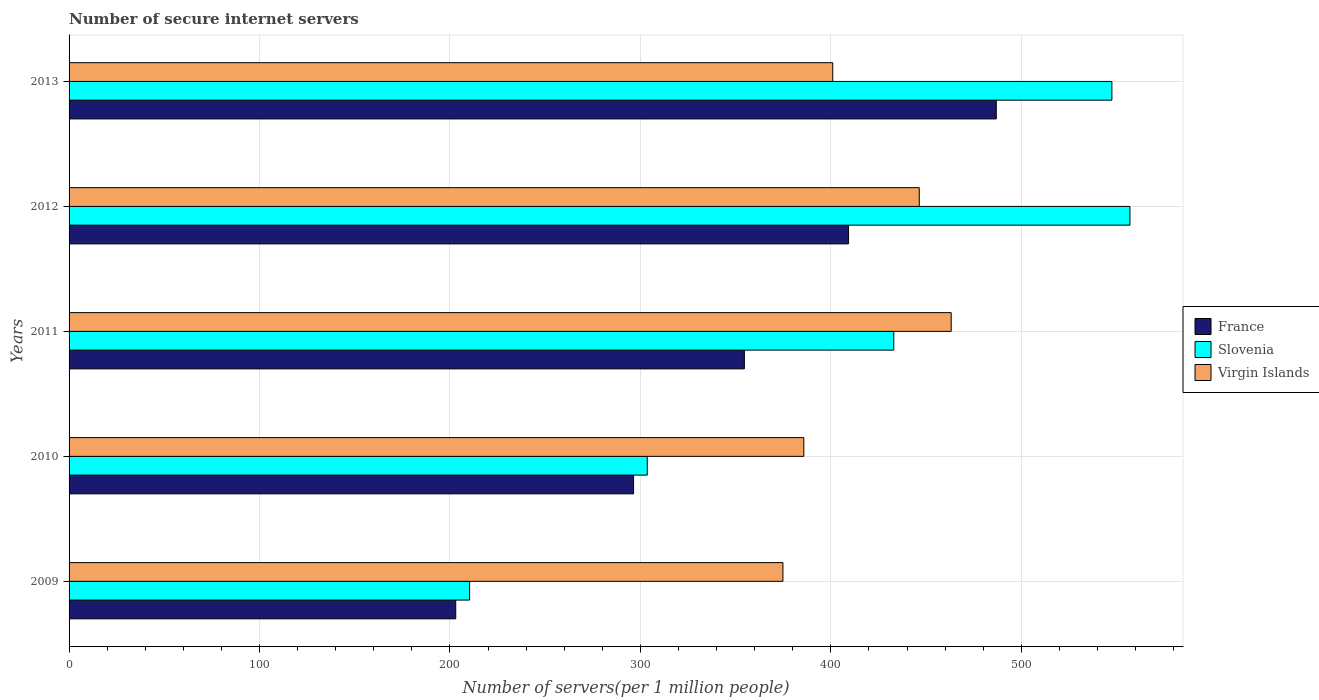How many groups of bars are there?
Keep it short and to the point. 5. Are the number of bars per tick equal to the number of legend labels?
Make the answer very short. Yes. How many bars are there on the 3rd tick from the top?
Your response must be concise. 3. How many bars are there on the 3rd tick from the bottom?
Provide a short and direct response. 3. What is the label of the 1st group of bars from the top?
Give a very brief answer. 2013. In how many cases, is the number of bars for a given year not equal to the number of legend labels?
Offer a terse response. 0. What is the number of secure internet servers in Virgin Islands in 2010?
Your answer should be very brief. 385.82. Across all years, what is the maximum number of secure internet servers in Virgin Islands?
Keep it short and to the point. 463.21. Across all years, what is the minimum number of secure internet servers in France?
Provide a succinct answer. 203.04. In which year was the number of secure internet servers in Slovenia maximum?
Your response must be concise. 2012. In which year was the number of secure internet servers in Slovenia minimum?
Give a very brief answer. 2009. What is the total number of secure internet servers in Slovenia in the graph?
Ensure brevity in your answer.  2051.67. What is the difference between the number of secure internet servers in France in 2011 and that in 2013?
Your answer should be very brief. -132.28. What is the difference between the number of secure internet servers in France in 2010 and the number of secure internet servers in Slovenia in 2011?
Provide a short and direct response. -136.64. What is the average number of secure internet servers in Virgin Islands per year?
Provide a short and direct response. 414.27. In the year 2013, what is the difference between the number of secure internet servers in Virgin Islands and number of secure internet servers in Slovenia?
Provide a succinct answer. -146.58. In how many years, is the number of secure internet servers in France greater than 160 ?
Offer a terse response. 5. What is the ratio of the number of secure internet servers in Slovenia in 2011 to that in 2012?
Your answer should be compact. 0.78. Is the number of secure internet servers in France in 2009 less than that in 2013?
Offer a terse response. Yes. Is the difference between the number of secure internet servers in Virgin Islands in 2010 and 2011 greater than the difference between the number of secure internet servers in Slovenia in 2010 and 2011?
Offer a very short reply. Yes. What is the difference between the highest and the second highest number of secure internet servers in France?
Offer a very short reply. 77.57. What is the difference between the highest and the lowest number of secure internet servers in France?
Your answer should be very brief. 283.84. What does the 2nd bar from the top in 2011 represents?
Keep it short and to the point. Slovenia. What does the 3rd bar from the bottom in 2012 represents?
Offer a very short reply. Virgin Islands. How many bars are there?
Your answer should be compact. 15. What is the difference between two consecutive major ticks on the X-axis?
Your answer should be very brief. 100. How many legend labels are there?
Your answer should be very brief. 3. What is the title of the graph?
Make the answer very short. Number of secure internet servers. Does "Panama" appear as one of the legend labels in the graph?
Provide a short and direct response. No. What is the label or title of the X-axis?
Ensure brevity in your answer.  Number of servers(per 1 million people). What is the Number of servers(per 1 million people) of France in 2009?
Your answer should be very brief. 203.04. What is the Number of servers(per 1 million people) in Slovenia in 2009?
Offer a terse response. 210.33. What is the Number of servers(per 1 million people) in Virgin Islands in 2009?
Provide a succinct answer. 374.86. What is the Number of servers(per 1 million people) in France in 2010?
Provide a short and direct response. 296.41. What is the Number of servers(per 1 million people) of Slovenia in 2010?
Ensure brevity in your answer.  303.62. What is the Number of servers(per 1 million people) of Virgin Islands in 2010?
Provide a short and direct response. 385.82. What is the Number of servers(per 1 million people) of France in 2011?
Provide a succinct answer. 354.61. What is the Number of servers(per 1 million people) in Slovenia in 2011?
Your answer should be compact. 433.06. What is the Number of servers(per 1 million people) of Virgin Islands in 2011?
Ensure brevity in your answer.  463.21. What is the Number of servers(per 1 million people) of France in 2012?
Offer a terse response. 409.31. What is the Number of servers(per 1 million people) of Slovenia in 2012?
Your response must be concise. 557.08. What is the Number of servers(per 1 million people) in Virgin Islands in 2012?
Your answer should be compact. 446.45. What is the Number of servers(per 1 million people) of France in 2013?
Give a very brief answer. 486.88. What is the Number of servers(per 1 million people) in Slovenia in 2013?
Provide a succinct answer. 547.59. What is the Number of servers(per 1 million people) in Virgin Islands in 2013?
Ensure brevity in your answer.  401. Across all years, what is the maximum Number of servers(per 1 million people) in France?
Offer a very short reply. 486.88. Across all years, what is the maximum Number of servers(per 1 million people) of Slovenia?
Make the answer very short. 557.08. Across all years, what is the maximum Number of servers(per 1 million people) of Virgin Islands?
Your answer should be very brief. 463.21. Across all years, what is the minimum Number of servers(per 1 million people) in France?
Provide a succinct answer. 203.04. Across all years, what is the minimum Number of servers(per 1 million people) of Slovenia?
Keep it short and to the point. 210.33. Across all years, what is the minimum Number of servers(per 1 million people) of Virgin Islands?
Your response must be concise. 374.86. What is the total Number of servers(per 1 million people) of France in the graph?
Offer a terse response. 1750.25. What is the total Number of servers(per 1 million people) of Slovenia in the graph?
Make the answer very short. 2051.68. What is the total Number of servers(per 1 million people) in Virgin Islands in the graph?
Your answer should be compact. 2071.34. What is the difference between the Number of servers(per 1 million people) in France in 2009 and that in 2010?
Your answer should be compact. -93.37. What is the difference between the Number of servers(per 1 million people) of Slovenia in 2009 and that in 2010?
Give a very brief answer. -93.3. What is the difference between the Number of servers(per 1 million people) in Virgin Islands in 2009 and that in 2010?
Your answer should be very brief. -10.96. What is the difference between the Number of servers(per 1 million people) in France in 2009 and that in 2011?
Provide a short and direct response. -151.57. What is the difference between the Number of servers(per 1 million people) of Slovenia in 2009 and that in 2011?
Give a very brief answer. -222.73. What is the difference between the Number of servers(per 1 million people) of Virgin Islands in 2009 and that in 2011?
Keep it short and to the point. -88.35. What is the difference between the Number of servers(per 1 million people) of France in 2009 and that in 2012?
Your answer should be compact. -206.27. What is the difference between the Number of servers(per 1 million people) in Slovenia in 2009 and that in 2012?
Ensure brevity in your answer.  -346.75. What is the difference between the Number of servers(per 1 million people) of Virgin Islands in 2009 and that in 2012?
Give a very brief answer. -71.59. What is the difference between the Number of servers(per 1 million people) of France in 2009 and that in 2013?
Offer a very short reply. -283.84. What is the difference between the Number of servers(per 1 million people) in Slovenia in 2009 and that in 2013?
Offer a very short reply. -337.26. What is the difference between the Number of servers(per 1 million people) in Virgin Islands in 2009 and that in 2013?
Your response must be concise. -26.15. What is the difference between the Number of servers(per 1 million people) of France in 2010 and that in 2011?
Make the answer very short. -58.19. What is the difference between the Number of servers(per 1 million people) in Slovenia in 2010 and that in 2011?
Give a very brief answer. -129.43. What is the difference between the Number of servers(per 1 million people) in Virgin Islands in 2010 and that in 2011?
Provide a succinct answer. -77.39. What is the difference between the Number of servers(per 1 million people) of France in 2010 and that in 2012?
Your response must be concise. -112.9. What is the difference between the Number of servers(per 1 million people) in Slovenia in 2010 and that in 2012?
Offer a very short reply. -253.45. What is the difference between the Number of servers(per 1 million people) of Virgin Islands in 2010 and that in 2012?
Give a very brief answer. -60.63. What is the difference between the Number of servers(per 1 million people) of France in 2010 and that in 2013?
Your answer should be very brief. -190.47. What is the difference between the Number of servers(per 1 million people) of Slovenia in 2010 and that in 2013?
Your answer should be very brief. -243.96. What is the difference between the Number of servers(per 1 million people) in Virgin Islands in 2010 and that in 2013?
Provide a short and direct response. -15.18. What is the difference between the Number of servers(per 1 million people) of France in 2011 and that in 2012?
Ensure brevity in your answer.  -54.7. What is the difference between the Number of servers(per 1 million people) in Slovenia in 2011 and that in 2012?
Ensure brevity in your answer.  -124.02. What is the difference between the Number of servers(per 1 million people) of Virgin Islands in 2011 and that in 2012?
Your response must be concise. 16.76. What is the difference between the Number of servers(per 1 million people) in France in 2011 and that in 2013?
Your answer should be compact. -132.28. What is the difference between the Number of servers(per 1 million people) in Slovenia in 2011 and that in 2013?
Offer a terse response. -114.53. What is the difference between the Number of servers(per 1 million people) in Virgin Islands in 2011 and that in 2013?
Offer a very short reply. 62.2. What is the difference between the Number of servers(per 1 million people) in France in 2012 and that in 2013?
Give a very brief answer. -77.57. What is the difference between the Number of servers(per 1 million people) in Slovenia in 2012 and that in 2013?
Offer a terse response. 9.49. What is the difference between the Number of servers(per 1 million people) in Virgin Islands in 2012 and that in 2013?
Your answer should be very brief. 45.45. What is the difference between the Number of servers(per 1 million people) of France in 2009 and the Number of servers(per 1 million people) of Slovenia in 2010?
Your answer should be very brief. -100.59. What is the difference between the Number of servers(per 1 million people) of France in 2009 and the Number of servers(per 1 million people) of Virgin Islands in 2010?
Your answer should be very brief. -182.78. What is the difference between the Number of servers(per 1 million people) in Slovenia in 2009 and the Number of servers(per 1 million people) in Virgin Islands in 2010?
Offer a very short reply. -175.49. What is the difference between the Number of servers(per 1 million people) of France in 2009 and the Number of servers(per 1 million people) of Slovenia in 2011?
Offer a very short reply. -230.02. What is the difference between the Number of servers(per 1 million people) of France in 2009 and the Number of servers(per 1 million people) of Virgin Islands in 2011?
Your response must be concise. -260.17. What is the difference between the Number of servers(per 1 million people) of Slovenia in 2009 and the Number of servers(per 1 million people) of Virgin Islands in 2011?
Your answer should be very brief. -252.88. What is the difference between the Number of servers(per 1 million people) in France in 2009 and the Number of servers(per 1 million people) in Slovenia in 2012?
Your answer should be compact. -354.04. What is the difference between the Number of servers(per 1 million people) in France in 2009 and the Number of servers(per 1 million people) in Virgin Islands in 2012?
Offer a very short reply. -243.41. What is the difference between the Number of servers(per 1 million people) of Slovenia in 2009 and the Number of servers(per 1 million people) of Virgin Islands in 2012?
Your answer should be very brief. -236.12. What is the difference between the Number of servers(per 1 million people) of France in 2009 and the Number of servers(per 1 million people) of Slovenia in 2013?
Keep it short and to the point. -344.55. What is the difference between the Number of servers(per 1 million people) in France in 2009 and the Number of servers(per 1 million people) in Virgin Islands in 2013?
Your response must be concise. -197.97. What is the difference between the Number of servers(per 1 million people) of Slovenia in 2009 and the Number of servers(per 1 million people) of Virgin Islands in 2013?
Offer a very short reply. -190.68. What is the difference between the Number of servers(per 1 million people) of France in 2010 and the Number of servers(per 1 million people) of Slovenia in 2011?
Your answer should be very brief. -136.65. What is the difference between the Number of servers(per 1 million people) in France in 2010 and the Number of servers(per 1 million people) in Virgin Islands in 2011?
Give a very brief answer. -166.79. What is the difference between the Number of servers(per 1 million people) of Slovenia in 2010 and the Number of servers(per 1 million people) of Virgin Islands in 2011?
Your answer should be very brief. -159.58. What is the difference between the Number of servers(per 1 million people) in France in 2010 and the Number of servers(per 1 million people) in Slovenia in 2012?
Your answer should be very brief. -260.67. What is the difference between the Number of servers(per 1 million people) in France in 2010 and the Number of servers(per 1 million people) in Virgin Islands in 2012?
Offer a terse response. -150.04. What is the difference between the Number of servers(per 1 million people) in Slovenia in 2010 and the Number of servers(per 1 million people) in Virgin Islands in 2012?
Ensure brevity in your answer.  -142.83. What is the difference between the Number of servers(per 1 million people) in France in 2010 and the Number of servers(per 1 million people) in Slovenia in 2013?
Your response must be concise. -251.17. What is the difference between the Number of servers(per 1 million people) in France in 2010 and the Number of servers(per 1 million people) in Virgin Islands in 2013?
Give a very brief answer. -104.59. What is the difference between the Number of servers(per 1 million people) in Slovenia in 2010 and the Number of servers(per 1 million people) in Virgin Islands in 2013?
Your response must be concise. -97.38. What is the difference between the Number of servers(per 1 million people) of France in 2011 and the Number of servers(per 1 million people) of Slovenia in 2012?
Your answer should be compact. -202.47. What is the difference between the Number of servers(per 1 million people) of France in 2011 and the Number of servers(per 1 million people) of Virgin Islands in 2012?
Keep it short and to the point. -91.84. What is the difference between the Number of servers(per 1 million people) of Slovenia in 2011 and the Number of servers(per 1 million people) of Virgin Islands in 2012?
Offer a terse response. -13.39. What is the difference between the Number of servers(per 1 million people) of France in 2011 and the Number of servers(per 1 million people) of Slovenia in 2013?
Keep it short and to the point. -192.98. What is the difference between the Number of servers(per 1 million people) of France in 2011 and the Number of servers(per 1 million people) of Virgin Islands in 2013?
Provide a short and direct response. -46.4. What is the difference between the Number of servers(per 1 million people) of Slovenia in 2011 and the Number of servers(per 1 million people) of Virgin Islands in 2013?
Provide a succinct answer. 32.05. What is the difference between the Number of servers(per 1 million people) of France in 2012 and the Number of servers(per 1 million people) of Slovenia in 2013?
Your response must be concise. -138.28. What is the difference between the Number of servers(per 1 million people) in France in 2012 and the Number of servers(per 1 million people) in Virgin Islands in 2013?
Your response must be concise. 8.3. What is the difference between the Number of servers(per 1 million people) of Slovenia in 2012 and the Number of servers(per 1 million people) of Virgin Islands in 2013?
Keep it short and to the point. 156.07. What is the average Number of servers(per 1 million people) in France per year?
Provide a short and direct response. 350.05. What is the average Number of servers(per 1 million people) in Slovenia per year?
Offer a terse response. 410.33. What is the average Number of servers(per 1 million people) of Virgin Islands per year?
Your answer should be very brief. 414.27. In the year 2009, what is the difference between the Number of servers(per 1 million people) in France and Number of servers(per 1 million people) in Slovenia?
Offer a terse response. -7.29. In the year 2009, what is the difference between the Number of servers(per 1 million people) in France and Number of servers(per 1 million people) in Virgin Islands?
Give a very brief answer. -171.82. In the year 2009, what is the difference between the Number of servers(per 1 million people) of Slovenia and Number of servers(per 1 million people) of Virgin Islands?
Provide a succinct answer. -164.53. In the year 2010, what is the difference between the Number of servers(per 1 million people) of France and Number of servers(per 1 million people) of Slovenia?
Your response must be concise. -7.21. In the year 2010, what is the difference between the Number of servers(per 1 million people) of France and Number of servers(per 1 million people) of Virgin Islands?
Offer a terse response. -89.41. In the year 2010, what is the difference between the Number of servers(per 1 million people) of Slovenia and Number of servers(per 1 million people) of Virgin Islands?
Ensure brevity in your answer.  -82.2. In the year 2011, what is the difference between the Number of servers(per 1 million people) of France and Number of servers(per 1 million people) of Slovenia?
Your answer should be very brief. -78.45. In the year 2011, what is the difference between the Number of servers(per 1 million people) of France and Number of servers(per 1 million people) of Virgin Islands?
Offer a terse response. -108.6. In the year 2011, what is the difference between the Number of servers(per 1 million people) in Slovenia and Number of servers(per 1 million people) in Virgin Islands?
Keep it short and to the point. -30.15. In the year 2012, what is the difference between the Number of servers(per 1 million people) of France and Number of servers(per 1 million people) of Slovenia?
Give a very brief answer. -147.77. In the year 2012, what is the difference between the Number of servers(per 1 million people) in France and Number of servers(per 1 million people) in Virgin Islands?
Provide a short and direct response. -37.14. In the year 2012, what is the difference between the Number of servers(per 1 million people) in Slovenia and Number of servers(per 1 million people) in Virgin Islands?
Provide a short and direct response. 110.63. In the year 2013, what is the difference between the Number of servers(per 1 million people) in France and Number of servers(per 1 million people) in Slovenia?
Your answer should be very brief. -60.7. In the year 2013, what is the difference between the Number of servers(per 1 million people) in France and Number of servers(per 1 million people) in Virgin Islands?
Make the answer very short. 85.88. In the year 2013, what is the difference between the Number of servers(per 1 million people) in Slovenia and Number of servers(per 1 million people) in Virgin Islands?
Make the answer very short. 146.58. What is the ratio of the Number of servers(per 1 million people) of France in 2009 to that in 2010?
Offer a very short reply. 0.69. What is the ratio of the Number of servers(per 1 million people) in Slovenia in 2009 to that in 2010?
Make the answer very short. 0.69. What is the ratio of the Number of servers(per 1 million people) in Virgin Islands in 2009 to that in 2010?
Provide a short and direct response. 0.97. What is the ratio of the Number of servers(per 1 million people) of France in 2009 to that in 2011?
Ensure brevity in your answer.  0.57. What is the ratio of the Number of servers(per 1 million people) in Slovenia in 2009 to that in 2011?
Offer a very short reply. 0.49. What is the ratio of the Number of servers(per 1 million people) of Virgin Islands in 2009 to that in 2011?
Ensure brevity in your answer.  0.81. What is the ratio of the Number of servers(per 1 million people) of France in 2009 to that in 2012?
Provide a succinct answer. 0.5. What is the ratio of the Number of servers(per 1 million people) in Slovenia in 2009 to that in 2012?
Your answer should be compact. 0.38. What is the ratio of the Number of servers(per 1 million people) in Virgin Islands in 2009 to that in 2012?
Keep it short and to the point. 0.84. What is the ratio of the Number of servers(per 1 million people) in France in 2009 to that in 2013?
Provide a short and direct response. 0.42. What is the ratio of the Number of servers(per 1 million people) in Slovenia in 2009 to that in 2013?
Provide a short and direct response. 0.38. What is the ratio of the Number of servers(per 1 million people) of Virgin Islands in 2009 to that in 2013?
Offer a terse response. 0.93. What is the ratio of the Number of servers(per 1 million people) of France in 2010 to that in 2011?
Your answer should be compact. 0.84. What is the ratio of the Number of servers(per 1 million people) of Slovenia in 2010 to that in 2011?
Provide a short and direct response. 0.7. What is the ratio of the Number of servers(per 1 million people) in Virgin Islands in 2010 to that in 2011?
Offer a very short reply. 0.83. What is the ratio of the Number of servers(per 1 million people) of France in 2010 to that in 2012?
Offer a very short reply. 0.72. What is the ratio of the Number of servers(per 1 million people) in Slovenia in 2010 to that in 2012?
Provide a short and direct response. 0.55. What is the ratio of the Number of servers(per 1 million people) in Virgin Islands in 2010 to that in 2012?
Provide a short and direct response. 0.86. What is the ratio of the Number of servers(per 1 million people) in France in 2010 to that in 2013?
Offer a terse response. 0.61. What is the ratio of the Number of servers(per 1 million people) of Slovenia in 2010 to that in 2013?
Make the answer very short. 0.55. What is the ratio of the Number of servers(per 1 million people) of Virgin Islands in 2010 to that in 2013?
Provide a short and direct response. 0.96. What is the ratio of the Number of servers(per 1 million people) of France in 2011 to that in 2012?
Your answer should be very brief. 0.87. What is the ratio of the Number of servers(per 1 million people) in Slovenia in 2011 to that in 2012?
Make the answer very short. 0.78. What is the ratio of the Number of servers(per 1 million people) of Virgin Islands in 2011 to that in 2012?
Keep it short and to the point. 1.04. What is the ratio of the Number of servers(per 1 million people) in France in 2011 to that in 2013?
Offer a very short reply. 0.73. What is the ratio of the Number of servers(per 1 million people) of Slovenia in 2011 to that in 2013?
Offer a very short reply. 0.79. What is the ratio of the Number of servers(per 1 million people) of Virgin Islands in 2011 to that in 2013?
Provide a succinct answer. 1.16. What is the ratio of the Number of servers(per 1 million people) in France in 2012 to that in 2013?
Your answer should be compact. 0.84. What is the ratio of the Number of servers(per 1 million people) of Slovenia in 2012 to that in 2013?
Offer a very short reply. 1.02. What is the ratio of the Number of servers(per 1 million people) of Virgin Islands in 2012 to that in 2013?
Provide a succinct answer. 1.11. What is the difference between the highest and the second highest Number of servers(per 1 million people) in France?
Your answer should be very brief. 77.57. What is the difference between the highest and the second highest Number of servers(per 1 million people) of Slovenia?
Give a very brief answer. 9.49. What is the difference between the highest and the second highest Number of servers(per 1 million people) in Virgin Islands?
Your response must be concise. 16.76. What is the difference between the highest and the lowest Number of servers(per 1 million people) in France?
Give a very brief answer. 283.84. What is the difference between the highest and the lowest Number of servers(per 1 million people) in Slovenia?
Ensure brevity in your answer.  346.75. What is the difference between the highest and the lowest Number of servers(per 1 million people) of Virgin Islands?
Give a very brief answer. 88.35. 